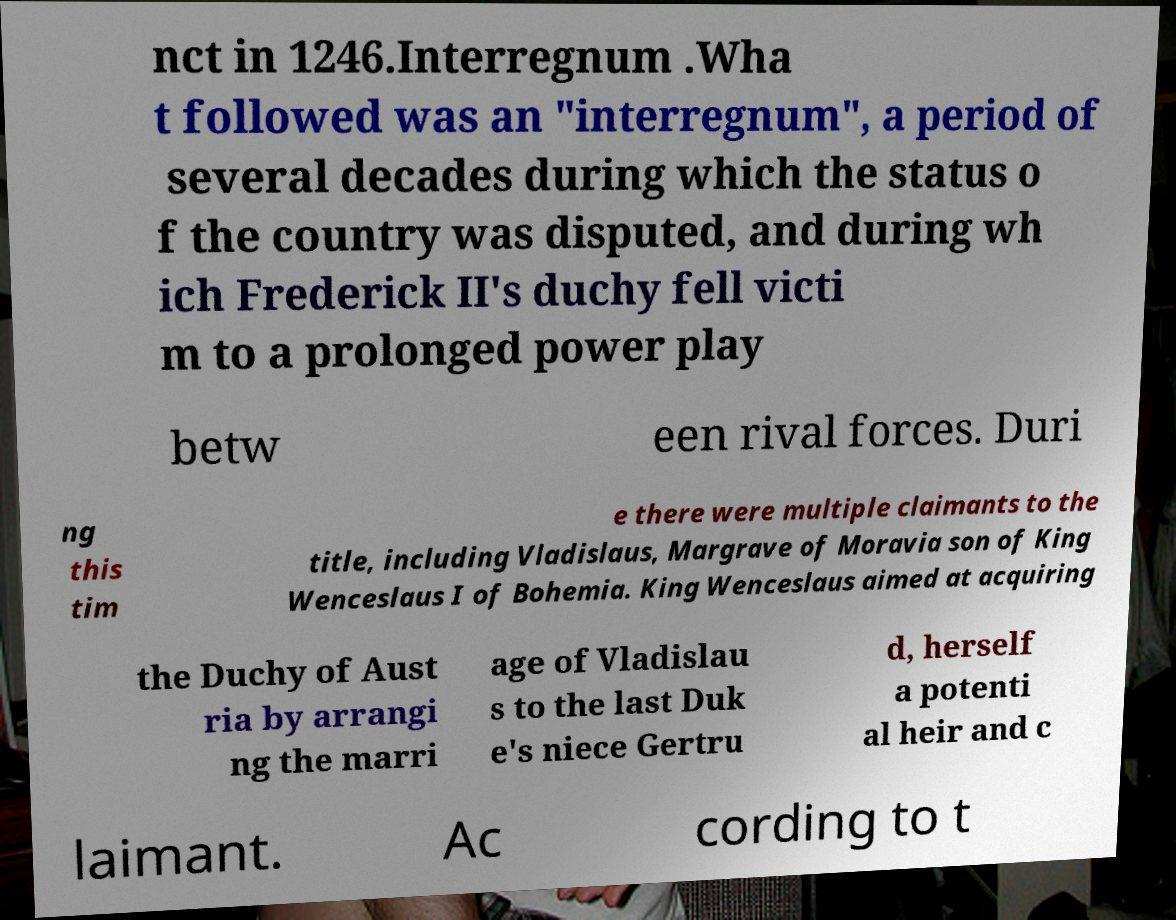What messages or text are displayed in this image? I need them in a readable, typed format. nct in 1246.Interregnum .Wha t followed was an "interregnum", a period of several decades during which the status o f the country was disputed, and during wh ich Frederick II's duchy fell victi m to a prolonged power play betw een rival forces. Duri ng this tim e there were multiple claimants to the title, including Vladislaus, Margrave of Moravia son of King Wenceslaus I of Bohemia. King Wenceslaus aimed at acquiring the Duchy of Aust ria by arrangi ng the marri age of Vladislau s to the last Duk e's niece Gertru d, herself a potenti al heir and c laimant. Ac cording to t 